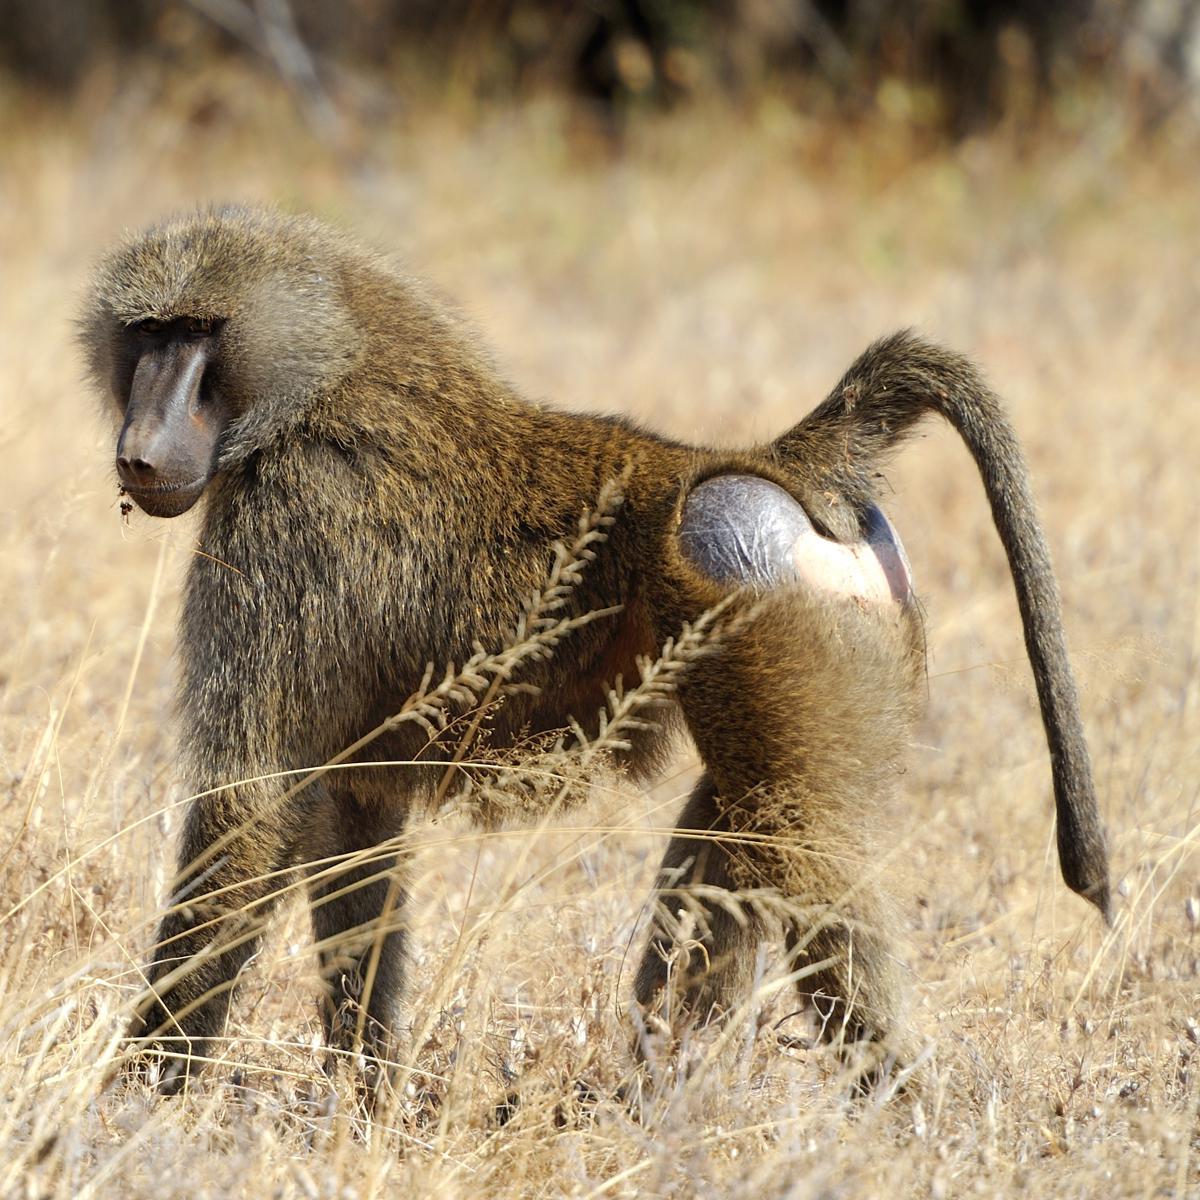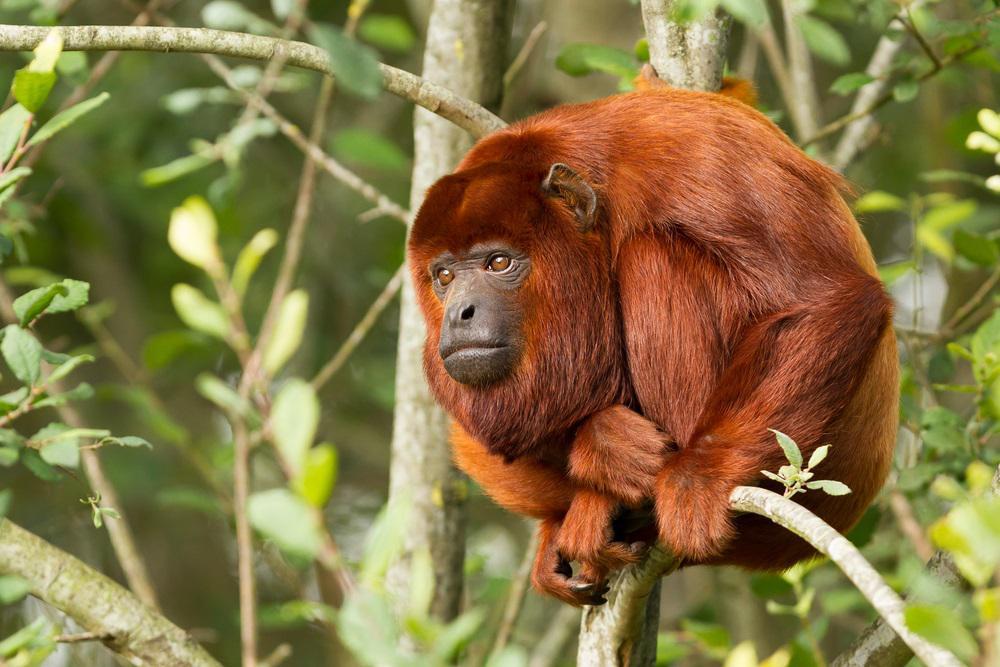The first image is the image on the left, the second image is the image on the right. Examine the images to the left and right. Is the description "A pink-faced baby baboo is held to the chest of its rightward-turned mother in one image." accurate? Answer yes or no. No. The first image is the image on the left, the second image is the image on the right. Examine the images to the left and right. Is the description "The right image contains at least two baboons." accurate? Answer yes or no. No. 